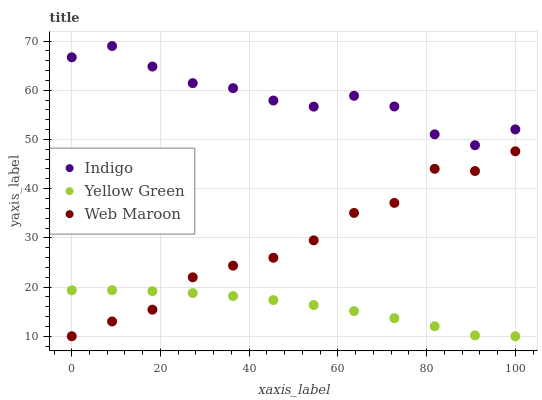Does Yellow Green have the minimum area under the curve?
Answer yes or no. Yes. Does Indigo have the maximum area under the curve?
Answer yes or no. Yes. Does Indigo have the minimum area under the curve?
Answer yes or no. No. Does Yellow Green have the maximum area under the curve?
Answer yes or no. No. Is Yellow Green the smoothest?
Answer yes or no. Yes. Is Web Maroon the roughest?
Answer yes or no. Yes. Is Indigo the smoothest?
Answer yes or no. No. Is Indigo the roughest?
Answer yes or no. No. Does Web Maroon have the lowest value?
Answer yes or no. Yes. Does Indigo have the lowest value?
Answer yes or no. No. Does Indigo have the highest value?
Answer yes or no. Yes. Does Yellow Green have the highest value?
Answer yes or no. No. Is Yellow Green less than Indigo?
Answer yes or no. Yes. Is Indigo greater than Web Maroon?
Answer yes or no. Yes. Does Web Maroon intersect Yellow Green?
Answer yes or no. Yes. Is Web Maroon less than Yellow Green?
Answer yes or no. No. Is Web Maroon greater than Yellow Green?
Answer yes or no. No. Does Yellow Green intersect Indigo?
Answer yes or no. No. 